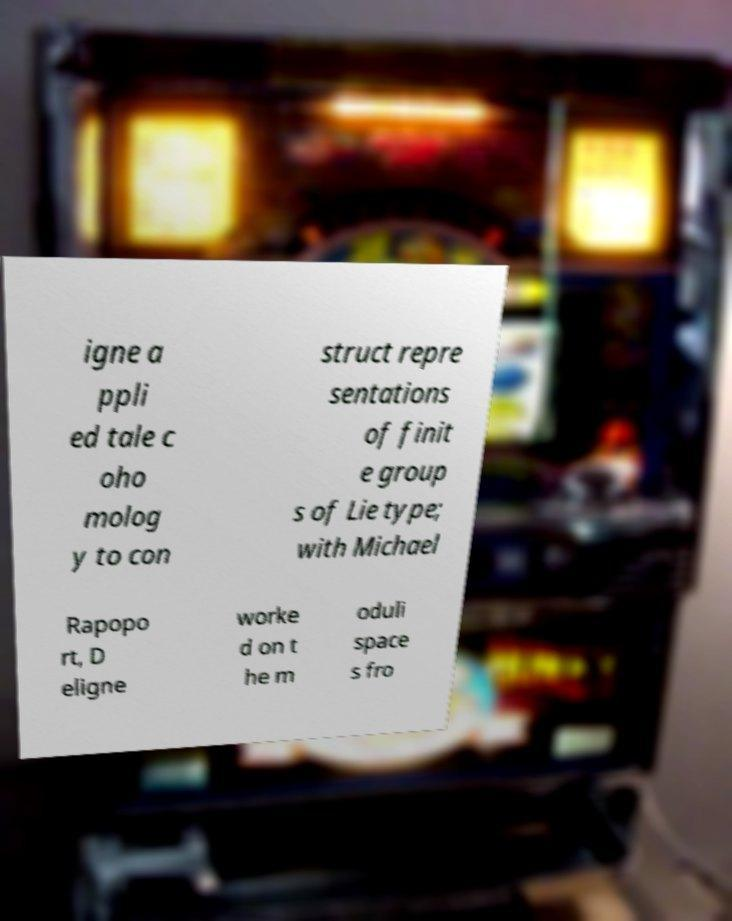Could you extract and type out the text from this image? igne a ppli ed tale c oho molog y to con struct repre sentations of finit e group s of Lie type; with Michael Rapopo rt, D eligne worke d on t he m oduli space s fro 